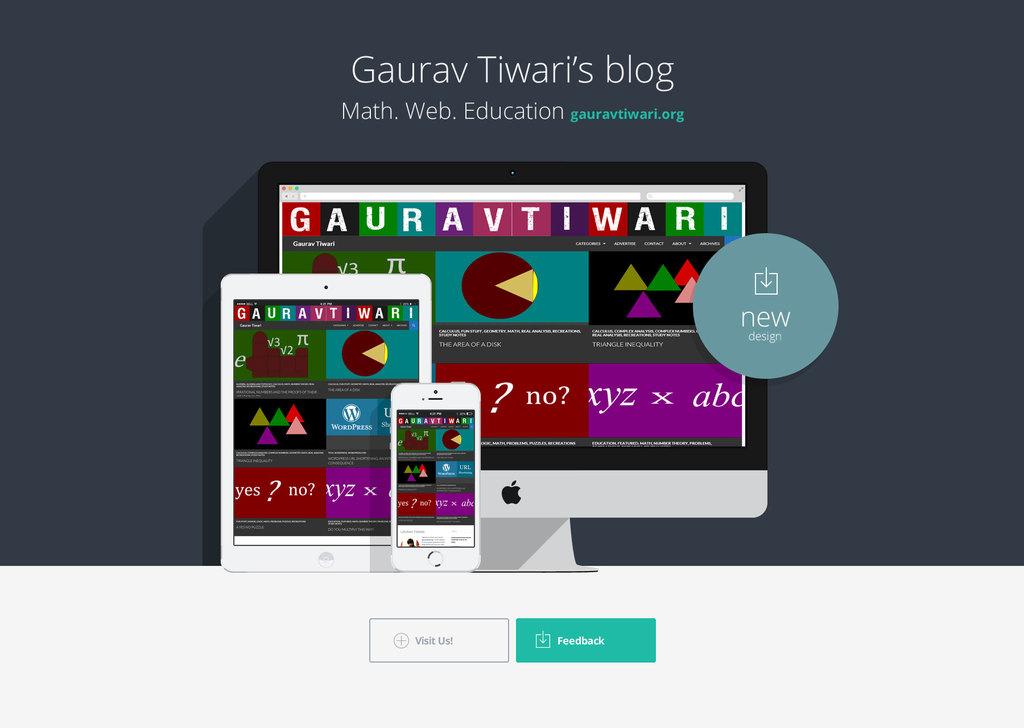Is gaurav's blog about only math education?
Ensure brevity in your answer.  No. Is it 1990's image?
Offer a terse response. No. 